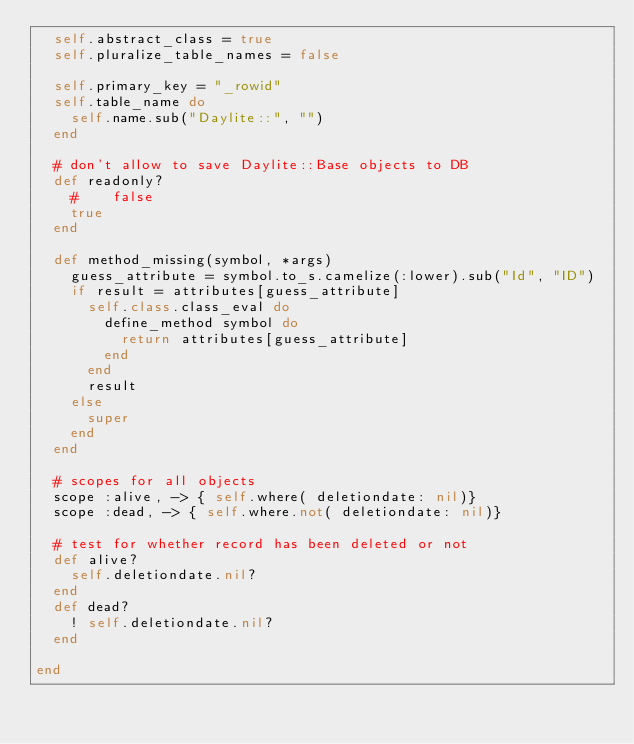<code> <loc_0><loc_0><loc_500><loc_500><_Ruby_>  self.abstract_class = true
  self.pluralize_table_names = false

  self.primary_key = "_rowid"
  self.table_name do
    self.name.sub("Daylite::", "")
  end

  # don't allow to save Daylite::Base objects to DB
  def readonly?
    #    false
    true
  end

  def method_missing(symbol, *args)
    guess_attribute = symbol.to_s.camelize(:lower).sub("Id", "ID")
    if result = attributes[guess_attribute]
      self.class.class_eval do
        define_method symbol do
          return attributes[guess_attribute]
        end
      end
      result
    else
      super
    end
  end

  # scopes for all objects
  scope :alive, -> { self.where( deletiondate: nil)}
  scope :dead, -> { self.where.not( deletiondate: nil)}

  # test for whether record has been deleted or not
  def alive?
    self.deletiondate.nil?
  end
  def dead?
    ! self.deletiondate.nil?
  end

end
</code> 